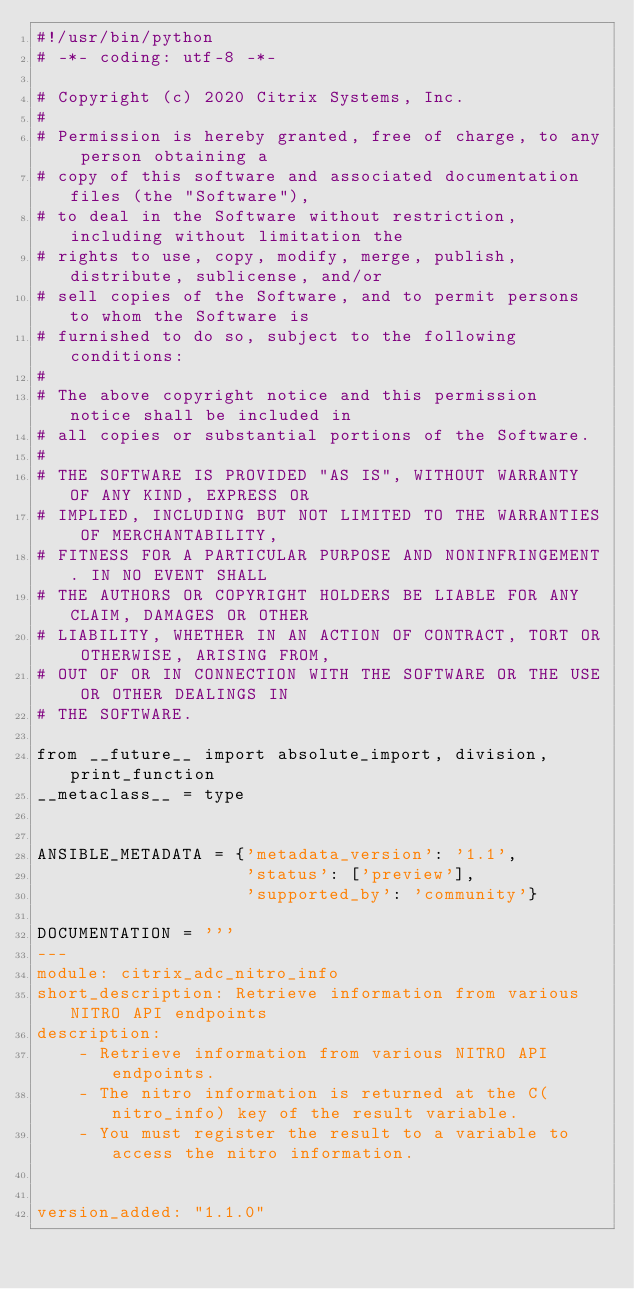<code> <loc_0><loc_0><loc_500><loc_500><_Python_>#!/usr/bin/python
# -*- coding: utf-8 -*-

# Copyright (c) 2020 Citrix Systems, Inc.
#
# Permission is hereby granted, free of charge, to any person obtaining a
# copy of this software and associated documentation files (the "Software"),
# to deal in the Software without restriction, including without limitation the
# rights to use, copy, modify, merge, publish, distribute, sublicense, and/or
# sell copies of the Software, and to permit persons to whom the Software is
# furnished to do so, subject to the following conditions:
#
# The above copyright notice and this permission notice shall be included in
# all copies or substantial portions of the Software.
#
# THE SOFTWARE IS PROVIDED "AS IS", WITHOUT WARRANTY OF ANY KIND, EXPRESS OR
# IMPLIED, INCLUDING BUT NOT LIMITED TO THE WARRANTIES OF MERCHANTABILITY,
# FITNESS FOR A PARTICULAR PURPOSE AND NONINFRINGEMENT. IN NO EVENT SHALL
# THE AUTHORS OR COPYRIGHT HOLDERS BE LIABLE FOR ANY CLAIM, DAMAGES OR OTHER
# LIABILITY, WHETHER IN AN ACTION OF CONTRACT, TORT OR OTHERWISE, ARISING FROM,
# OUT OF OR IN CONNECTION WITH THE SOFTWARE OR THE USE OR OTHER DEALINGS IN
# THE SOFTWARE.

from __future__ import absolute_import, division, print_function
__metaclass__ = type


ANSIBLE_METADATA = {'metadata_version': '1.1',
                    'status': ['preview'],
                    'supported_by': 'community'}

DOCUMENTATION = '''
---
module: citrix_adc_nitro_info
short_description: Retrieve information from various NITRO API endpoints
description:
    - Retrieve information from various NITRO API endpoints.
    - The nitro information is returned at the C(nitro_info) key of the result variable.
    - You must register the result to a variable to access the nitro information.


version_added: "1.1.0"
</code> 